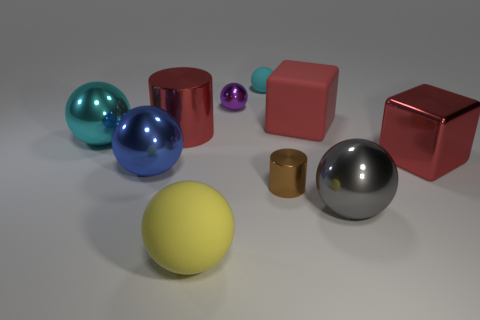There is another cube that is the same color as the big shiny block; what is it made of?
Offer a terse response. Rubber. There is a cyan ball that is behind the big red rubber cube; does it have the same size as the brown cylinder that is right of the large red cylinder?
Your answer should be compact. Yes. What is the color of the cylinder that is to the left of the tiny metal cylinder?
Your answer should be very brief. Red. Are there fewer metallic objects that are behind the small brown cylinder than big cylinders?
Give a very brief answer. No. Are the purple thing and the large blue object made of the same material?
Provide a short and direct response. Yes. What size is the yellow thing that is the same shape as the big blue object?
Ensure brevity in your answer.  Large. How many objects are red shiny things left of the rubber block or cyan balls in front of the large red rubber block?
Give a very brief answer. 2. Are there fewer small purple objects than cylinders?
Give a very brief answer. Yes. Is the size of the shiny cube the same as the object that is behind the tiny purple shiny thing?
Ensure brevity in your answer.  No. What number of matte objects are either big green things or large yellow things?
Keep it short and to the point. 1. 